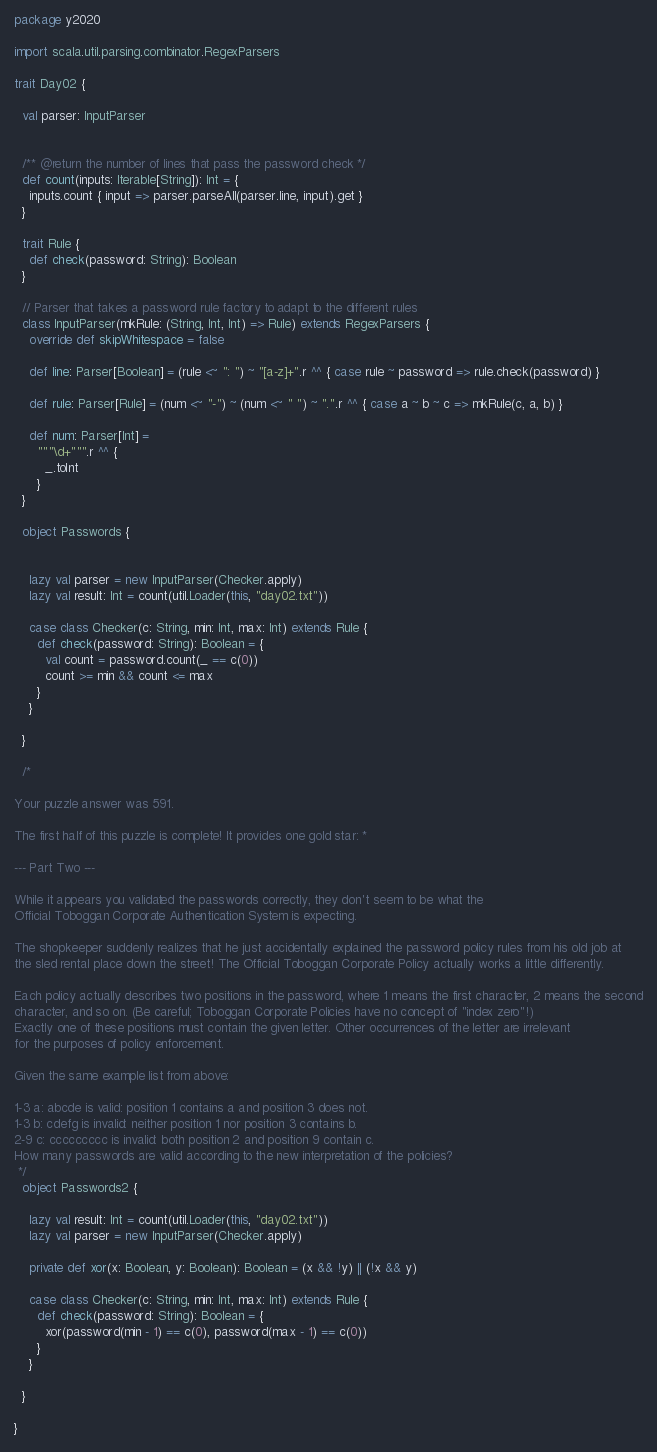Convert code to text. <code><loc_0><loc_0><loc_500><loc_500><_Scala_>package y2020

import scala.util.parsing.combinator.RegexParsers

trait Day02 {

  val parser: InputParser


  /** @return the number of lines that pass the password check */
  def count(inputs: Iterable[String]): Int = {
    inputs.count { input => parser.parseAll(parser.line, input).get }
  }

  trait Rule {
    def check(password: String): Boolean
  }

  // Parser that takes a password rule factory to adapt to the different rules
  class InputParser(mkRule: (String, Int, Int) => Rule) extends RegexParsers {
    override def skipWhitespace = false

    def line: Parser[Boolean] = (rule <~ ": ") ~ "[a-z]+".r ^^ { case rule ~ password => rule.check(password) }

    def rule: Parser[Rule] = (num <~ "-") ~ (num <~ " ") ~ ".".r ^^ { case a ~ b ~ c => mkRule(c, a, b) }

    def num: Parser[Int] =
      """\d+""".r ^^ {
        _.toInt
      }
  }

  object Passwords {


    lazy val parser = new InputParser(Checker.apply)
    lazy val result: Int = count(util.Loader(this, "day02.txt"))

    case class Checker(c: String, min: Int, max: Int) extends Rule {
      def check(password: String): Boolean = {
        val count = password.count(_ == c(0))
        count >= min && count <= max
      }
    }

  }

  /*

Your puzzle answer was 591.

The first half of this puzzle is complete! It provides one gold star: *

--- Part Two ---

While it appears you validated the passwords correctly, they don't seem to be what the
Official Toboggan Corporate Authentication System is expecting.

The shopkeeper suddenly realizes that he just accidentally explained the password policy rules from his old job at
the sled rental place down the street! The Official Toboggan Corporate Policy actually works a little differently.

Each policy actually describes two positions in the password, where 1 means the first character, 2 means the second
character, and so on. (Be careful; Toboggan Corporate Policies have no concept of "index zero"!)
Exactly one of these positions must contain the given letter. Other occurrences of the letter are irrelevant
for the purposes of policy enforcement.

Given the same example list from above:

1-3 a: abcde is valid: position 1 contains a and position 3 does not.
1-3 b: cdefg is invalid: neither position 1 nor position 3 contains b.
2-9 c: ccccccccc is invalid: both position 2 and position 9 contain c.
How many passwords are valid according to the new interpretation of the policies?
 */
  object Passwords2 {

    lazy val result: Int = count(util.Loader(this, "day02.txt"))
    lazy val parser = new InputParser(Checker.apply)

    private def xor(x: Boolean, y: Boolean): Boolean = (x && !y) || (!x && y)

    case class Checker(c: String, min: Int, max: Int) extends Rule {
      def check(password: String): Boolean = {
        xor(password(min - 1) == c(0), password(max - 1) == c(0))
      }
    }

  }

}
</code> 